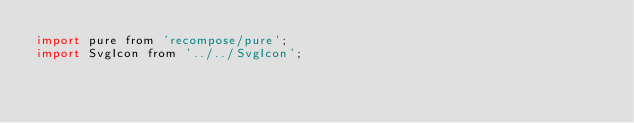<code> <loc_0><loc_0><loc_500><loc_500><_JavaScript_>import pure from 'recompose/pure';
import SvgIcon from '../../SvgIcon';
</code> 